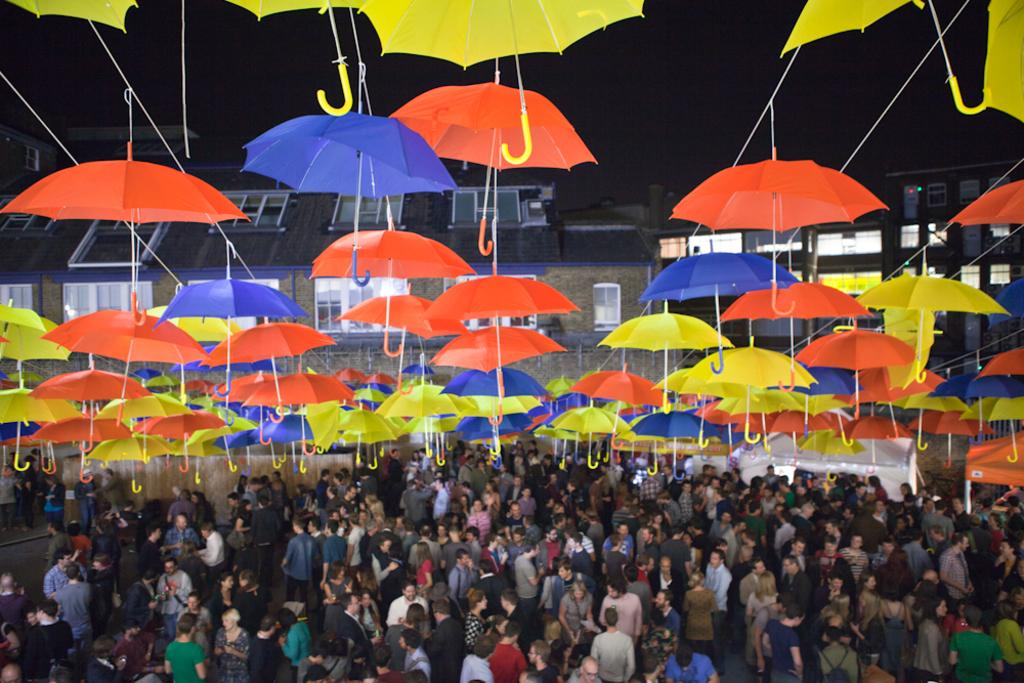What is happening in the image? There are people standing in the image. What are the people holding in the image? There are umbrellas in the image. What colors are the umbrellas? The umbrellas are in yellow, orange, and blue colors. What can be seen in the background of the image? There are homes visible in the background of the image. Are there any memories being shared between the people in the image? There is no indication of memories being shared in the image; it only shows people standing with umbrellas. What type of bag is being used to carry the umbrellas in the image? There is no bag visible in the image; the umbrellas are being held by the people. 